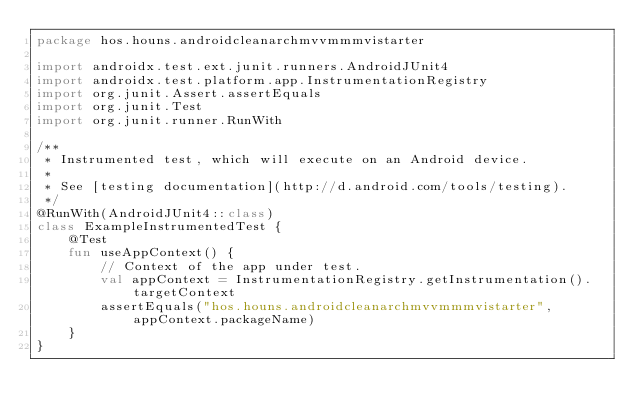Convert code to text. <code><loc_0><loc_0><loc_500><loc_500><_Kotlin_>package hos.houns.androidcleanarchmvvmmmvistarter

import androidx.test.ext.junit.runners.AndroidJUnit4
import androidx.test.platform.app.InstrumentationRegistry
import org.junit.Assert.assertEquals
import org.junit.Test
import org.junit.runner.RunWith

/**
 * Instrumented test, which will execute on an Android device.
 *
 * See [testing documentation](http://d.android.com/tools/testing).
 */
@RunWith(AndroidJUnit4::class)
class ExampleInstrumentedTest {
    @Test
    fun useAppContext() {
        // Context of the app under test.
        val appContext = InstrumentationRegistry.getInstrumentation().targetContext
        assertEquals("hos.houns.androidcleanarchmvvmmmvistarter", appContext.packageName)
    }
}</code> 